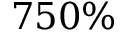<formula> <loc_0><loc_0><loc_500><loc_500>7 5 0 \%</formula> 